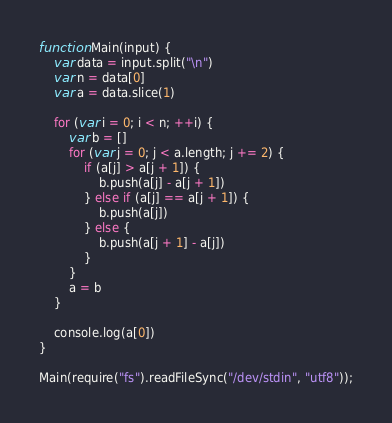Convert code to text. <code><loc_0><loc_0><loc_500><loc_500><_JavaScript_>function Main(input) {
	var data = input.split("\n")
	var n = data[0]
	var a = data.slice(1)
	
	for (var i = 0; i < n; ++i) {
		var b = []
		for (var j = 0; j < a.length; j += 2) {
			if (a[j] > a[j + 1]) {
				b.push(a[j] - a[j + 1])
			} else if (a[j] == a[j + 1]) {
				b.push(a[j])
			} else {
				b.push(a[j + 1] - a[j])
			}
		}
		a = b
	}
	
	console.log(a[0])
}

Main(require("fs").readFileSync("/dev/stdin", "utf8"));
</code> 